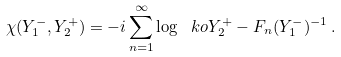<formula> <loc_0><loc_0><loc_500><loc_500>\chi ( Y _ { 1 } ^ { - } , Y _ { 2 } ^ { + } ) = - i \sum _ { n = 1 } ^ { \infty } \log \ k o { Y _ { 2 } ^ { + } - F _ { n } ( Y _ { 1 } ^ { - } ) ^ { - 1 } } \, .</formula> 